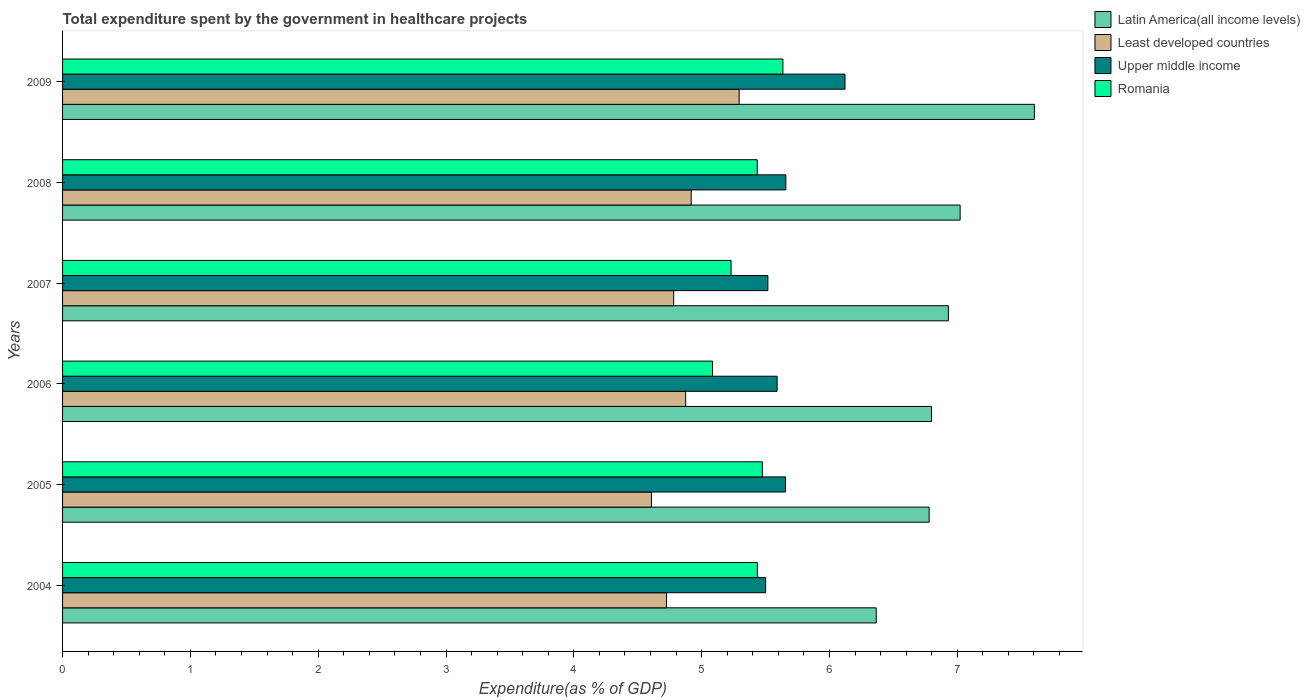How many different coloured bars are there?
Keep it short and to the point. 4. How many groups of bars are there?
Your answer should be compact. 6. Are the number of bars per tick equal to the number of legend labels?
Your answer should be compact. Yes. Are the number of bars on each tick of the Y-axis equal?
Keep it short and to the point. Yes. What is the label of the 5th group of bars from the top?
Keep it short and to the point. 2005. In how many cases, is the number of bars for a given year not equal to the number of legend labels?
Provide a succinct answer. 0. What is the total expenditure spent by the government in healthcare projects in Romania in 2004?
Your answer should be very brief. 5.44. Across all years, what is the maximum total expenditure spent by the government in healthcare projects in Upper middle income?
Ensure brevity in your answer.  6.12. Across all years, what is the minimum total expenditure spent by the government in healthcare projects in Latin America(all income levels)?
Provide a short and direct response. 6.37. In which year was the total expenditure spent by the government in healthcare projects in Upper middle income maximum?
Offer a very short reply. 2009. What is the total total expenditure spent by the government in healthcare projects in Least developed countries in the graph?
Ensure brevity in your answer.  29.2. What is the difference between the total expenditure spent by the government in healthcare projects in Least developed countries in 2005 and that in 2008?
Offer a terse response. -0.31. What is the difference between the total expenditure spent by the government in healthcare projects in Least developed countries in 2004 and the total expenditure spent by the government in healthcare projects in Upper middle income in 2008?
Your answer should be compact. -0.93. What is the average total expenditure spent by the government in healthcare projects in Least developed countries per year?
Your response must be concise. 4.87. In the year 2007, what is the difference between the total expenditure spent by the government in healthcare projects in Upper middle income and total expenditure spent by the government in healthcare projects in Latin America(all income levels)?
Your answer should be compact. -1.41. What is the ratio of the total expenditure spent by the government in healthcare projects in Upper middle income in 2005 to that in 2009?
Provide a short and direct response. 0.92. Is the total expenditure spent by the government in healthcare projects in Least developed countries in 2005 less than that in 2009?
Give a very brief answer. Yes. What is the difference between the highest and the second highest total expenditure spent by the government in healthcare projects in Least developed countries?
Make the answer very short. 0.38. What is the difference between the highest and the lowest total expenditure spent by the government in healthcare projects in Upper middle income?
Your answer should be very brief. 0.62. Is it the case that in every year, the sum of the total expenditure spent by the government in healthcare projects in Least developed countries and total expenditure spent by the government in healthcare projects in Romania is greater than the sum of total expenditure spent by the government in healthcare projects in Latin America(all income levels) and total expenditure spent by the government in healthcare projects in Upper middle income?
Offer a terse response. No. What does the 1st bar from the top in 2007 represents?
Provide a succinct answer. Romania. What does the 3rd bar from the bottom in 2009 represents?
Your answer should be compact. Upper middle income. Is it the case that in every year, the sum of the total expenditure spent by the government in healthcare projects in Least developed countries and total expenditure spent by the government in healthcare projects in Latin America(all income levels) is greater than the total expenditure spent by the government in healthcare projects in Romania?
Make the answer very short. Yes. Are all the bars in the graph horizontal?
Your answer should be very brief. Yes. How many years are there in the graph?
Make the answer very short. 6. Does the graph contain any zero values?
Provide a succinct answer. No. How many legend labels are there?
Your answer should be compact. 4. What is the title of the graph?
Your answer should be compact. Total expenditure spent by the government in healthcare projects. What is the label or title of the X-axis?
Make the answer very short. Expenditure(as % of GDP). What is the label or title of the Y-axis?
Provide a succinct answer. Years. What is the Expenditure(as % of GDP) in Latin America(all income levels) in 2004?
Your response must be concise. 6.37. What is the Expenditure(as % of GDP) of Least developed countries in 2004?
Your response must be concise. 4.72. What is the Expenditure(as % of GDP) of Upper middle income in 2004?
Make the answer very short. 5.5. What is the Expenditure(as % of GDP) in Romania in 2004?
Provide a succinct answer. 5.44. What is the Expenditure(as % of GDP) of Latin America(all income levels) in 2005?
Give a very brief answer. 6.78. What is the Expenditure(as % of GDP) of Least developed countries in 2005?
Give a very brief answer. 4.61. What is the Expenditure(as % of GDP) in Upper middle income in 2005?
Provide a short and direct response. 5.66. What is the Expenditure(as % of GDP) of Romania in 2005?
Ensure brevity in your answer.  5.48. What is the Expenditure(as % of GDP) in Latin America(all income levels) in 2006?
Offer a very short reply. 6.8. What is the Expenditure(as % of GDP) in Least developed countries in 2006?
Provide a short and direct response. 4.88. What is the Expenditure(as % of GDP) in Upper middle income in 2006?
Provide a succinct answer. 5.59. What is the Expenditure(as % of GDP) of Romania in 2006?
Keep it short and to the point. 5.09. What is the Expenditure(as % of GDP) in Latin America(all income levels) in 2007?
Ensure brevity in your answer.  6.93. What is the Expenditure(as % of GDP) in Least developed countries in 2007?
Offer a terse response. 4.78. What is the Expenditure(as % of GDP) in Upper middle income in 2007?
Provide a short and direct response. 5.52. What is the Expenditure(as % of GDP) in Romania in 2007?
Provide a succinct answer. 5.23. What is the Expenditure(as % of GDP) of Latin America(all income levels) in 2008?
Make the answer very short. 7.02. What is the Expenditure(as % of GDP) of Least developed countries in 2008?
Your response must be concise. 4.92. What is the Expenditure(as % of GDP) of Upper middle income in 2008?
Provide a short and direct response. 5.66. What is the Expenditure(as % of GDP) of Romania in 2008?
Keep it short and to the point. 5.44. What is the Expenditure(as % of GDP) in Latin America(all income levels) in 2009?
Offer a terse response. 7.6. What is the Expenditure(as % of GDP) in Least developed countries in 2009?
Keep it short and to the point. 5.29. What is the Expenditure(as % of GDP) of Upper middle income in 2009?
Make the answer very short. 6.12. What is the Expenditure(as % of GDP) in Romania in 2009?
Offer a very short reply. 5.64. Across all years, what is the maximum Expenditure(as % of GDP) in Latin America(all income levels)?
Make the answer very short. 7.6. Across all years, what is the maximum Expenditure(as % of GDP) of Least developed countries?
Make the answer very short. 5.29. Across all years, what is the maximum Expenditure(as % of GDP) of Upper middle income?
Make the answer very short. 6.12. Across all years, what is the maximum Expenditure(as % of GDP) of Romania?
Your answer should be very brief. 5.64. Across all years, what is the minimum Expenditure(as % of GDP) of Latin America(all income levels)?
Provide a short and direct response. 6.37. Across all years, what is the minimum Expenditure(as % of GDP) in Least developed countries?
Your answer should be compact. 4.61. Across all years, what is the minimum Expenditure(as % of GDP) of Upper middle income?
Your answer should be very brief. 5.5. Across all years, what is the minimum Expenditure(as % of GDP) in Romania?
Your answer should be very brief. 5.09. What is the total Expenditure(as % of GDP) of Latin America(all income levels) in the graph?
Offer a terse response. 41.5. What is the total Expenditure(as % of GDP) in Least developed countries in the graph?
Offer a very short reply. 29.2. What is the total Expenditure(as % of GDP) in Upper middle income in the graph?
Keep it short and to the point. 34.05. What is the total Expenditure(as % of GDP) in Romania in the graph?
Your answer should be compact. 32.3. What is the difference between the Expenditure(as % of GDP) of Latin America(all income levels) in 2004 and that in 2005?
Your answer should be very brief. -0.41. What is the difference between the Expenditure(as % of GDP) of Least developed countries in 2004 and that in 2005?
Offer a very short reply. 0.12. What is the difference between the Expenditure(as % of GDP) of Upper middle income in 2004 and that in 2005?
Provide a succinct answer. -0.15. What is the difference between the Expenditure(as % of GDP) of Romania in 2004 and that in 2005?
Provide a succinct answer. -0.04. What is the difference between the Expenditure(as % of GDP) in Latin America(all income levels) in 2004 and that in 2006?
Provide a short and direct response. -0.43. What is the difference between the Expenditure(as % of GDP) in Least developed countries in 2004 and that in 2006?
Make the answer very short. -0.15. What is the difference between the Expenditure(as % of GDP) of Upper middle income in 2004 and that in 2006?
Offer a very short reply. -0.09. What is the difference between the Expenditure(as % of GDP) in Romania in 2004 and that in 2006?
Ensure brevity in your answer.  0.35. What is the difference between the Expenditure(as % of GDP) of Latin America(all income levels) in 2004 and that in 2007?
Give a very brief answer. -0.56. What is the difference between the Expenditure(as % of GDP) of Least developed countries in 2004 and that in 2007?
Give a very brief answer. -0.06. What is the difference between the Expenditure(as % of GDP) of Upper middle income in 2004 and that in 2007?
Ensure brevity in your answer.  -0.02. What is the difference between the Expenditure(as % of GDP) of Romania in 2004 and that in 2007?
Your answer should be compact. 0.21. What is the difference between the Expenditure(as % of GDP) in Latin America(all income levels) in 2004 and that in 2008?
Make the answer very short. -0.66. What is the difference between the Expenditure(as % of GDP) in Least developed countries in 2004 and that in 2008?
Make the answer very short. -0.19. What is the difference between the Expenditure(as % of GDP) of Upper middle income in 2004 and that in 2008?
Provide a short and direct response. -0.16. What is the difference between the Expenditure(as % of GDP) in Romania in 2004 and that in 2008?
Give a very brief answer. 0. What is the difference between the Expenditure(as % of GDP) in Latin America(all income levels) in 2004 and that in 2009?
Offer a very short reply. -1.24. What is the difference between the Expenditure(as % of GDP) in Least developed countries in 2004 and that in 2009?
Ensure brevity in your answer.  -0.57. What is the difference between the Expenditure(as % of GDP) in Upper middle income in 2004 and that in 2009?
Give a very brief answer. -0.62. What is the difference between the Expenditure(as % of GDP) of Romania in 2004 and that in 2009?
Your answer should be very brief. -0.2. What is the difference between the Expenditure(as % of GDP) in Latin America(all income levels) in 2005 and that in 2006?
Make the answer very short. -0.02. What is the difference between the Expenditure(as % of GDP) of Least developed countries in 2005 and that in 2006?
Provide a succinct answer. -0.27. What is the difference between the Expenditure(as % of GDP) in Upper middle income in 2005 and that in 2006?
Ensure brevity in your answer.  0.07. What is the difference between the Expenditure(as % of GDP) in Romania in 2005 and that in 2006?
Ensure brevity in your answer.  0.39. What is the difference between the Expenditure(as % of GDP) in Latin America(all income levels) in 2005 and that in 2007?
Your answer should be very brief. -0.15. What is the difference between the Expenditure(as % of GDP) in Least developed countries in 2005 and that in 2007?
Your answer should be compact. -0.17. What is the difference between the Expenditure(as % of GDP) of Upper middle income in 2005 and that in 2007?
Your answer should be very brief. 0.14. What is the difference between the Expenditure(as % of GDP) of Romania in 2005 and that in 2007?
Your answer should be very brief. 0.24. What is the difference between the Expenditure(as % of GDP) in Latin America(all income levels) in 2005 and that in 2008?
Offer a very short reply. -0.24. What is the difference between the Expenditure(as % of GDP) of Least developed countries in 2005 and that in 2008?
Provide a short and direct response. -0.31. What is the difference between the Expenditure(as % of GDP) of Upper middle income in 2005 and that in 2008?
Provide a short and direct response. -0. What is the difference between the Expenditure(as % of GDP) of Romania in 2005 and that in 2008?
Your answer should be compact. 0.04. What is the difference between the Expenditure(as % of GDP) of Latin America(all income levels) in 2005 and that in 2009?
Offer a terse response. -0.82. What is the difference between the Expenditure(as % of GDP) of Least developed countries in 2005 and that in 2009?
Offer a terse response. -0.69. What is the difference between the Expenditure(as % of GDP) in Upper middle income in 2005 and that in 2009?
Offer a very short reply. -0.47. What is the difference between the Expenditure(as % of GDP) in Romania in 2005 and that in 2009?
Your response must be concise. -0.16. What is the difference between the Expenditure(as % of GDP) of Latin America(all income levels) in 2006 and that in 2007?
Keep it short and to the point. -0.13. What is the difference between the Expenditure(as % of GDP) in Least developed countries in 2006 and that in 2007?
Provide a short and direct response. 0.09. What is the difference between the Expenditure(as % of GDP) of Upper middle income in 2006 and that in 2007?
Your response must be concise. 0.07. What is the difference between the Expenditure(as % of GDP) of Romania in 2006 and that in 2007?
Your response must be concise. -0.15. What is the difference between the Expenditure(as % of GDP) in Latin America(all income levels) in 2006 and that in 2008?
Provide a succinct answer. -0.22. What is the difference between the Expenditure(as % of GDP) of Least developed countries in 2006 and that in 2008?
Give a very brief answer. -0.04. What is the difference between the Expenditure(as % of GDP) of Upper middle income in 2006 and that in 2008?
Give a very brief answer. -0.07. What is the difference between the Expenditure(as % of GDP) of Romania in 2006 and that in 2008?
Your response must be concise. -0.35. What is the difference between the Expenditure(as % of GDP) of Latin America(all income levels) in 2006 and that in 2009?
Keep it short and to the point. -0.8. What is the difference between the Expenditure(as % of GDP) of Least developed countries in 2006 and that in 2009?
Your answer should be very brief. -0.42. What is the difference between the Expenditure(as % of GDP) in Upper middle income in 2006 and that in 2009?
Keep it short and to the point. -0.53. What is the difference between the Expenditure(as % of GDP) in Romania in 2006 and that in 2009?
Make the answer very short. -0.55. What is the difference between the Expenditure(as % of GDP) in Latin America(all income levels) in 2007 and that in 2008?
Ensure brevity in your answer.  -0.09. What is the difference between the Expenditure(as % of GDP) of Least developed countries in 2007 and that in 2008?
Make the answer very short. -0.14. What is the difference between the Expenditure(as % of GDP) in Upper middle income in 2007 and that in 2008?
Provide a short and direct response. -0.14. What is the difference between the Expenditure(as % of GDP) in Romania in 2007 and that in 2008?
Give a very brief answer. -0.2. What is the difference between the Expenditure(as % of GDP) in Latin America(all income levels) in 2007 and that in 2009?
Your answer should be very brief. -0.67. What is the difference between the Expenditure(as % of GDP) in Least developed countries in 2007 and that in 2009?
Ensure brevity in your answer.  -0.51. What is the difference between the Expenditure(as % of GDP) in Upper middle income in 2007 and that in 2009?
Offer a very short reply. -0.6. What is the difference between the Expenditure(as % of GDP) of Romania in 2007 and that in 2009?
Your response must be concise. -0.41. What is the difference between the Expenditure(as % of GDP) of Latin America(all income levels) in 2008 and that in 2009?
Keep it short and to the point. -0.58. What is the difference between the Expenditure(as % of GDP) of Least developed countries in 2008 and that in 2009?
Your answer should be very brief. -0.38. What is the difference between the Expenditure(as % of GDP) in Upper middle income in 2008 and that in 2009?
Provide a short and direct response. -0.46. What is the difference between the Expenditure(as % of GDP) of Romania in 2008 and that in 2009?
Your answer should be compact. -0.2. What is the difference between the Expenditure(as % of GDP) in Latin America(all income levels) in 2004 and the Expenditure(as % of GDP) in Least developed countries in 2005?
Offer a very short reply. 1.76. What is the difference between the Expenditure(as % of GDP) in Latin America(all income levels) in 2004 and the Expenditure(as % of GDP) in Upper middle income in 2005?
Your response must be concise. 0.71. What is the difference between the Expenditure(as % of GDP) of Latin America(all income levels) in 2004 and the Expenditure(as % of GDP) of Romania in 2005?
Offer a terse response. 0.89. What is the difference between the Expenditure(as % of GDP) in Least developed countries in 2004 and the Expenditure(as % of GDP) in Upper middle income in 2005?
Your answer should be very brief. -0.93. What is the difference between the Expenditure(as % of GDP) in Least developed countries in 2004 and the Expenditure(as % of GDP) in Romania in 2005?
Your answer should be compact. -0.75. What is the difference between the Expenditure(as % of GDP) in Upper middle income in 2004 and the Expenditure(as % of GDP) in Romania in 2005?
Your answer should be compact. 0.03. What is the difference between the Expenditure(as % of GDP) in Latin America(all income levels) in 2004 and the Expenditure(as % of GDP) in Least developed countries in 2006?
Keep it short and to the point. 1.49. What is the difference between the Expenditure(as % of GDP) of Latin America(all income levels) in 2004 and the Expenditure(as % of GDP) of Upper middle income in 2006?
Give a very brief answer. 0.78. What is the difference between the Expenditure(as % of GDP) in Latin America(all income levels) in 2004 and the Expenditure(as % of GDP) in Romania in 2006?
Keep it short and to the point. 1.28. What is the difference between the Expenditure(as % of GDP) in Least developed countries in 2004 and the Expenditure(as % of GDP) in Upper middle income in 2006?
Make the answer very short. -0.87. What is the difference between the Expenditure(as % of GDP) of Least developed countries in 2004 and the Expenditure(as % of GDP) of Romania in 2006?
Your answer should be very brief. -0.36. What is the difference between the Expenditure(as % of GDP) of Upper middle income in 2004 and the Expenditure(as % of GDP) of Romania in 2006?
Offer a terse response. 0.42. What is the difference between the Expenditure(as % of GDP) in Latin America(all income levels) in 2004 and the Expenditure(as % of GDP) in Least developed countries in 2007?
Ensure brevity in your answer.  1.58. What is the difference between the Expenditure(as % of GDP) of Latin America(all income levels) in 2004 and the Expenditure(as % of GDP) of Upper middle income in 2007?
Offer a very short reply. 0.85. What is the difference between the Expenditure(as % of GDP) of Latin America(all income levels) in 2004 and the Expenditure(as % of GDP) of Romania in 2007?
Your answer should be very brief. 1.14. What is the difference between the Expenditure(as % of GDP) in Least developed countries in 2004 and the Expenditure(as % of GDP) in Upper middle income in 2007?
Ensure brevity in your answer.  -0.79. What is the difference between the Expenditure(as % of GDP) of Least developed countries in 2004 and the Expenditure(as % of GDP) of Romania in 2007?
Provide a short and direct response. -0.51. What is the difference between the Expenditure(as % of GDP) of Upper middle income in 2004 and the Expenditure(as % of GDP) of Romania in 2007?
Your response must be concise. 0.27. What is the difference between the Expenditure(as % of GDP) in Latin America(all income levels) in 2004 and the Expenditure(as % of GDP) in Least developed countries in 2008?
Provide a succinct answer. 1.45. What is the difference between the Expenditure(as % of GDP) of Latin America(all income levels) in 2004 and the Expenditure(as % of GDP) of Upper middle income in 2008?
Give a very brief answer. 0.71. What is the difference between the Expenditure(as % of GDP) in Least developed countries in 2004 and the Expenditure(as % of GDP) in Upper middle income in 2008?
Ensure brevity in your answer.  -0.93. What is the difference between the Expenditure(as % of GDP) in Least developed countries in 2004 and the Expenditure(as % of GDP) in Romania in 2008?
Offer a very short reply. -0.71. What is the difference between the Expenditure(as % of GDP) in Upper middle income in 2004 and the Expenditure(as % of GDP) in Romania in 2008?
Give a very brief answer. 0.07. What is the difference between the Expenditure(as % of GDP) of Latin America(all income levels) in 2004 and the Expenditure(as % of GDP) of Least developed countries in 2009?
Your answer should be compact. 1.07. What is the difference between the Expenditure(as % of GDP) in Latin America(all income levels) in 2004 and the Expenditure(as % of GDP) in Upper middle income in 2009?
Keep it short and to the point. 0.24. What is the difference between the Expenditure(as % of GDP) of Latin America(all income levels) in 2004 and the Expenditure(as % of GDP) of Romania in 2009?
Provide a succinct answer. 0.73. What is the difference between the Expenditure(as % of GDP) in Least developed countries in 2004 and the Expenditure(as % of GDP) in Upper middle income in 2009?
Your answer should be very brief. -1.4. What is the difference between the Expenditure(as % of GDP) of Least developed countries in 2004 and the Expenditure(as % of GDP) of Romania in 2009?
Keep it short and to the point. -0.91. What is the difference between the Expenditure(as % of GDP) of Upper middle income in 2004 and the Expenditure(as % of GDP) of Romania in 2009?
Make the answer very short. -0.14. What is the difference between the Expenditure(as % of GDP) in Latin America(all income levels) in 2005 and the Expenditure(as % of GDP) in Least developed countries in 2006?
Your answer should be compact. 1.9. What is the difference between the Expenditure(as % of GDP) of Latin America(all income levels) in 2005 and the Expenditure(as % of GDP) of Upper middle income in 2006?
Your answer should be compact. 1.19. What is the difference between the Expenditure(as % of GDP) of Latin America(all income levels) in 2005 and the Expenditure(as % of GDP) of Romania in 2006?
Your response must be concise. 1.69. What is the difference between the Expenditure(as % of GDP) in Least developed countries in 2005 and the Expenditure(as % of GDP) in Upper middle income in 2006?
Provide a succinct answer. -0.98. What is the difference between the Expenditure(as % of GDP) in Least developed countries in 2005 and the Expenditure(as % of GDP) in Romania in 2006?
Your response must be concise. -0.48. What is the difference between the Expenditure(as % of GDP) in Upper middle income in 2005 and the Expenditure(as % of GDP) in Romania in 2006?
Offer a terse response. 0.57. What is the difference between the Expenditure(as % of GDP) in Latin America(all income levels) in 2005 and the Expenditure(as % of GDP) in Least developed countries in 2007?
Make the answer very short. 2. What is the difference between the Expenditure(as % of GDP) of Latin America(all income levels) in 2005 and the Expenditure(as % of GDP) of Upper middle income in 2007?
Your answer should be very brief. 1.26. What is the difference between the Expenditure(as % of GDP) in Latin America(all income levels) in 2005 and the Expenditure(as % of GDP) in Romania in 2007?
Your response must be concise. 1.55. What is the difference between the Expenditure(as % of GDP) of Least developed countries in 2005 and the Expenditure(as % of GDP) of Upper middle income in 2007?
Offer a terse response. -0.91. What is the difference between the Expenditure(as % of GDP) of Least developed countries in 2005 and the Expenditure(as % of GDP) of Romania in 2007?
Offer a very short reply. -0.62. What is the difference between the Expenditure(as % of GDP) in Upper middle income in 2005 and the Expenditure(as % of GDP) in Romania in 2007?
Your response must be concise. 0.43. What is the difference between the Expenditure(as % of GDP) in Latin America(all income levels) in 2005 and the Expenditure(as % of GDP) in Least developed countries in 2008?
Make the answer very short. 1.86. What is the difference between the Expenditure(as % of GDP) in Latin America(all income levels) in 2005 and the Expenditure(as % of GDP) in Upper middle income in 2008?
Give a very brief answer. 1.12. What is the difference between the Expenditure(as % of GDP) in Latin America(all income levels) in 2005 and the Expenditure(as % of GDP) in Romania in 2008?
Offer a terse response. 1.34. What is the difference between the Expenditure(as % of GDP) in Least developed countries in 2005 and the Expenditure(as % of GDP) in Upper middle income in 2008?
Offer a very short reply. -1.05. What is the difference between the Expenditure(as % of GDP) of Least developed countries in 2005 and the Expenditure(as % of GDP) of Romania in 2008?
Offer a terse response. -0.83. What is the difference between the Expenditure(as % of GDP) in Upper middle income in 2005 and the Expenditure(as % of GDP) in Romania in 2008?
Offer a terse response. 0.22. What is the difference between the Expenditure(as % of GDP) of Latin America(all income levels) in 2005 and the Expenditure(as % of GDP) of Least developed countries in 2009?
Provide a short and direct response. 1.49. What is the difference between the Expenditure(as % of GDP) of Latin America(all income levels) in 2005 and the Expenditure(as % of GDP) of Upper middle income in 2009?
Offer a very short reply. 0.66. What is the difference between the Expenditure(as % of GDP) of Latin America(all income levels) in 2005 and the Expenditure(as % of GDP) of Romania in 2009?
Offer a very short reply. 1.14. What is the difference between the Expenditure(as % of GDP) in Least developed countries in 2005 and the Expenditure(as % of GDP) in Upper middle income in 2009?
Provide a succinct answer. -1.51. What is the difference between the Expenditure(as % of GDP) of Least developed countries in 2005 and the Expenditure(as % of GDP) of Romania in 2009?
Give a very brief answer. -1.03. What is the difference between the Expenditure(as % of GDP) of Upper middle income in 2005 and the Expenditure(as % of GDP) of Romania in 2009?
Ensure brevity in your answer.  0.02. What is the difference between the Expenditure(as % of GDP) in Latin America(all income levels) in 2006 and the Expenditure(as % of GDP) in Least developed countries in 2007?
Provide a short and direct response. 2.02. What is the difference between the Expenditure(as % of GDP) of Latin America(all income levels) in 2006 and the Expenditure(as % of GDP) of Upper middle income in 2007?
Offer a very short reply. 1.28. What is the difference between the Expenditure(as % of GDP) in Latin America(all income levels) in 2006 and the Expenditure(as % of GDP) in Romania in 2007?
Make the answer very short. 1.57. What is the difference between the Expenditure(as % of GDP) of Least developed countries in 2006 and the Expenditure(as % of GDP) of Upper middle income in 2007?
Your response must be concise. -0.64. What is the difference between the Expenditure(as % of GDP) in Least developed countries in 2006 and the Expenditure(as % of GDP) in Romania in 2007?
Give a very brief answer. -0.36. What is the difference between the Expenditure(as % of GDP) of Upper middle income in 2006 and the Expenditure(as % of GDP) of Romania in 2007?
Offer a terse response. 0.36. What is the difference between the Expenditure(as % of GDP) in Latin America(all income levels) in 2006 and the Expenditure(as % of GDP) in Least developed countries in 2008?
Provide a succinct answer. 1.88. What is the difference between the Expenditure(as % of GDP) of Latin America(all income levels) in 2006 and the Expenditure(as % of GDP) of Upper middle income in 2008?
Offer a very short reply. 1.14. What is the difference between the Expenditure(as % of GDP) of Latin America(all income levels) in 2006 and the Expenditure(as % of GDP) of Romania in 2008?
Provide a succinct answer. 1.36. What is the difference between the Expenditure(as % of GDP) in Least developed countries in 2006 and the Expenditure(as % of GDP) in Upper middle income in 2008?
Provide a short and direct response. -0.78. What is the difference between the Expenditure(as % of GDP) of Least developed countries in 2006 and the Expenditure(as % of GDP) of Romania in 2008?
Make the answer very short. -0.56. What is the difference between the Expenditure(as % of GDP) of Upper middle income in 2006 and the Expenditure(as % of GDP) of Romania in 2008?
Your answer should be compact. 0.16. What is the difference between the Expenditure(as % of GDP) in Latin America(all income levels) in 2006 and the Expenditure(as % of GDP) in Least developed countries in 2009?
Ensure brevity in your answer.  1.51. What is the difference between the Expenditure(as % of GDP) of Latin America(all income levels) in 2006 and the Expenditure(as % of GDP) of Upper middle income in 2009?
Give a very brief answer. 0.68. What is the difference between the Expenditure(as % of GDP) in Latin America(all income levels) in 2006 and the Expenditure(as % of GDP) in Romania in 2009?
Your answer should be compact. 1.16. What is the difference between the Expenditure(as % of GDP) in Least developed countries in 2006 and the Expenditure(as % of GDP) in Upper middle income in 2009?
Your response must be concise. -1.25. What is the difference between the Expenditure(as % of GDP) of Least developed countries in 2006 and the Expenditure(as % of GDP) of Romania in 2009?
Provide a short and direct response. -0.76. What is the difference between the Expenditure(as % of GDP) in Upper middle income in 2006 and the Expenditure(as % of GDP) in Romania in 2009?
Ensure brevity in your answer.  -0.05. What is the difference between the Expenditure(as % of GDP) in Latin America(all income levels) in 2007 and the Expenditure(as % of GDP) in Least developed countries in 2008?
Offer a very short reply. 2.01. What is the difference between the Expenditure(as % of GDP) in Latin America(all income levels) in 2007 and the Expenditure(as % of GDP) in Upper middle income in 2008?
Provide a short and direct response. 1.27. What is the difference between the Expenditure(as % of GDP) of Latin America(all income levels) in 2007 and the Expenditure(as % of GDP) of Romania in 2008?
Your answer should be very brief. 1.5. What is the difference between the Expenditure(as % of GDP) in Least developed countries in 2007 and the Expenditure(as % of GDP) in Upper middle income in 2008?
Keep it short and to the point. -0.88. What is the difference between the Expenditure(as % of GDP) of Least developed countries in 2007 and the Expenditure(as % of GDP) of Romania in 2008?
Ensure brevity in your answer.  -0.65. What is the difference between the Expenditure(as % of GDP) in Upper middle income in 2007 and the Expenditure(as % of GDP) in Romania in 2008?
Ensure brevity in your answer.  0.08. What is the difference between the Expenditure(as % of GDP) in Latin America(all income levels) in 2007 and the Expenditure(as % of GDP) in Least developed countries in 2009?
Give a very brief answer. 1.64. What is the difference between the Expenditure(as % of GDP) of Latin America(all income levels) in 2007 and the Expenditure(as % of GDP) of Upper middle income in 2009?
Keep it short and to the point. 0.81. What is the difference between the Expenditure(as % of GDP) in Latin America(all income levels) in 2007 and the Expenditure(as % of GDP) in Romania in 2009?
Your answer should be very brief. 1.29. What is the difference between the Expenditure(as % of GDP) of Least developed countries in 2007 and the Expenditure(as % of GDP) of Upper middle income in 2009?
Offer a very short reply. -1.34. What is the difference between the Expenditure(as % of GDP) of Least developed countries in 2007 and the Expenditure(as % of GDP) of Romania in 2009?
Provide a succinct answer. -0.85. What is the difference between the Expenditure(as % of GDP) of Upper middle income in 2007 and the Expenditure(as % of GDP) of Romania in 2009?
Provide a succinct answer. -0.12. What is the difference between the Expenditure(as % of GDP) of Latin America(all income levels) in 2008 and the Expenditure(as % of GDP) of Least developed countries in 2009?
Provide a succinct answer. 1.73. What is the difference between the Expenditure(as % of GDP) of Latin America(all income levels) in 2008 and the Expenditure(as % of GDP) of Upper middle income in 2009?
Give a very brief answer. 0.9. What is the difference between the Expenditure(as % of GDP) of Latin America(all income levels) in 2008 and the Expenditure(as % of GDP) of Romania in 2009?
Provide a succinct answer. 1.39. What is the difference between the Expenditure(as % of GDP) of Least developed countries in 2008 and the Expenditure(as % of GDP) of Upper middle income in 2009?
Provide a succinct answer. -1.2. What is the difference between the Expenditure(as % of GDP) in Least developed countries in 2008 and the Expenditure(as % of GDP) in Romania in 2009?
Your response must be concise. -0.72. What is the difference between the Expenditure(as % of GDP) of Upper middle income in 2008 and the Expenditure(as % of GDP) of Romania in 2009?
Provide a succinct answer. 0.02. What is the average Expenditure(as % of GDP) in Latin America(all income levels) per year?
Keep it short and to the point. 6.92. What is the average Expenditure(as % of GDP) of Least developed countries per year?
Offer a terse response. 4.87. What is the average Expenditure(as % of GDP) in Upper middle income per year?
Your response must be concise. 5.67. What is the average Expenditure(as % of GDP) in Romania per year?
Offer a terse response. 5.38. In the year 2004, what is the difference between the Expenditure(as % of GDP) of Latin America(all income levels) and Expenditure(as % of GDP) of Least developed countries?
Ensure brevity in your answer.  1.64. In the year 2004, what is the difference between the Expenditure(as % of GDP) of Latin America(all income levels) and Expenditure(as % of GDP) of Upper middle income?
Keep it short and to the point. 0.87. In the year 2004, what is the difference between the Expenditure(as % of GDP) of Latin America(all income levels) and Expenditure(as % of GDP) of Romania?
Your answer should be very brief. 0.93. In the year 2004, what is the difference between the Expenditure(as % of GDP) of Least developed countries and Expenditure(as % of GDP) of Upper middle income?
Give a very brief answer. -0.78. In the year 2004, what is the difference between the Expenditure(as % of GDP) in Least developed countries and Expenditure(as % of GDP) in Romania?
Ensure brevity in your answer.  -0.71. In the year 2004, what is the difference between the Expenditure(as % of GDP) of Upper middle income and Expenditure(as % of GDP) of Romania?
Ensure brevity in your answer.  0.06. In the year 2005, what is the difference between the Expenditure(as % of GDP) of Latin America(all income levels) and Expenditure(as % of GDP) of Least developed countries?
Your answer should be compact. 2.17. In the year 2005, what is the difference between the Expenditure(as % of GDP) in Latin America(all income levels) and Expenditure(as % of GDP) in Upper middle income?
Offer a terse response. 1.12. In the year 2005, what is the difference between the Expenditure(as % of GDP) of Latin America(all income levels) and Expenditure(as % of GDP) of Romania?
Make the answer very short. 1.31. In the year 2005, what is the difference between the Expenditure(as % of GDP) of Least developed countries and Expenditure(as % of GDP) of Upper middle income?
Your answer should be compact. -1.05. In the year 2005, what is the difference between the Expenditure(as % of GDP) of Least developed countries and Expenditure(as % of GDP) of Romania?
Make the answer very short. -0.87. In the year 2005, what is the difference between the Expenditure(as % of GDP) in Upper middle income and Expenditure(as % of GDP) in Romania?
Your answer should be compact. 0.18. In the year 2006, what is the difference between the Expenditure(as % of GDP) in Latin America(all income levels) and Expenditure(as % of GDP) in Least developed countries?
Offer a terse response. 1.92. In the year 2006, what is the difference between the Expenditure(as % of GDP) of Latin America(all income levels) and Expenditure(as % of GDP) of Upper middle income?
Offer a very short reply. 1.21. In the year 2006, what is the difference between the Expenditure(as % of GDP) of Latin America(all income levels) and Expenditure(as % of GDP) of Romania?
Provide a short and direct response. 1.71. In the year 2006, what is the difference between the Expenditure(as % of GDP) of Least developed countries and Expenditure(as % of GDP) of Upper middle income?
Your answer should be compact. -0.72. In the year 2006, what is the difference between the Expenditure(as % of GDP) of Least developed countries and Expenditure(as % of GDP) of Romania?
Provide a succinct answer. -0.21. In the year 2006, what is the difference between the Expenditure(as % of GDP) of Upper middle income and Expenditure(as % of GDP) of Romania?
Offer a terse response. 0.51. In the year 2007, what is the difference between the Expenditure(as % of GDP) in Latin America(all income levels) and Expenditure(as % of GDP) in Least developed countries?
Provide a short and direct response. 2.15. In the year 2007, what is the difference between the Expenditure(as % of GDP) in Latin America(all income levels) and Expenditure(as % of GDP) in Upper middle income?
Give a very brief answer. 1.41. In the year 2007, what is the difference between the Expenditure(as % of GDP) in Latin America(all income levels) and Expenditure(as % of GDP) in Romania?
Offer a very short reply. 1.7. In the year 2007, what is the difference between the Expenditure(as % of GDP) in Least developed countries and Expenditure(as % of GDP) in Upper middle income?
Offer a terse response. -0.74. In the year 2007, what is the difference between the Expenditure(as % of GDP) of Least developed countries and Expenditure(as % of GDP) of Romania?
Ensure brevity in your answer.  -0.45. In the year 2007, what is the difference between the Expenditure(as % of GDP) of Upper middle income and Expenditure(as % of GDP) of Romania?
Give a very brief answer. 0.29. In the year 2008, what is the difference between the Expenditure(as % of GDP) of Latin America(all income levels) and Expenditure(as % of GDP) of Least developed countries?
Keep it short and to the point. 2.1. In the year 2008, what is the difference between the Expenditure(as % of GDP) in Latin America(all income levels) and Expenditure(as % of GDP) in Upper middle income?
Your answer should be compact. 1.36. In the year 2008, what is the difference between the Expenditure(as % of GDP) in Latin America(all income levels) and Expenditure(as % of GDP) in Romania?
Make the answer very short. 1.59. In the year 2008, what is the difference between the Expenditure(as % of GDP) in Least developed countries and Expenditure(as % of GDP) in Upper middle income?
Keep it short and to the point. -0.74. In the year 2008, what is the difference between the Expenditure(as % of GDP) in Least developed countries and Expenditure(as % of GDP) in Romania?
Your response must be concise. -0.52. In the year 2008, what is the difference between the Expenditure(as % of GDP) in Upper middle income and Expenditure(as % of GDP) in Romania?
Ensure brevity in your answer.  0.22. In the year 2009, what is the difference between the Expenditure(as % of GDP) in Latin America(all income levels) and Expenditure(as % of GDP) in Least developed countries?
Provide a succinct answer. 2.31. In the year 2009, what is the difference between the Expenditure(as % of GDP) in Latin America(all income levels) and Expenditure(as % of GDP) in Upper middle income?
Your answer should be compact. 1.48. In the year 2009, what is the difference between the Expenditure(as % of GDP) of Latin America(all income levels) and Expenditure(as % of GDP) of Romania?
Give a very brief answer. 1.97. In the year 2009, what is the difference between the Expenditure(as % of GDP) in Least developed countries and Expenditure(as % of GDP) in Upper middle income?
Your response must be concise. -0.83. In the year 2009, what is the difference between the Expenditure(as % of GDP) in Least developed countries and Expenditure(as % of GDP) in Romania?
Your response must be concise. -0.34. In the year 2009, what is the difference between the Expenditure(as % of GDP) of Upper middle income and Expenditure(as % of GDP) of Romania?
Your answer should be compact. 0.49. What is the ratio of the Expenditure(as % of GDP) in Latin America(all income levels) in 2004 to that in 2005?
Ensure brevity in your answer.  0.94. What is the ratio of the Expenditure(as % of GDP) of Least developed countries in 2004 to that in 2005?
Offer a very short reply. 1.03. What is the ratio of the Expenditure(as % of GDP) of Upper middle income in 2004 to that in 2005?
Your answer should be very brief. 0.97. What is the ratio of the Expenditure(as % of GDP) of Latin America(all income levels) in 2004 to that in 2006?
Give a very brief answer. 0.94. What is the ratio of the Expenditure(as % of GDP) of Least developed countries in 2004 to that in 2006?
Provide a succinct answer. 0.97. What is the ratio of the Expenditure(as % of GDP) of Upper middle income in 2004 to that in 2006?
Offer a very short reply. 0.98. What is the ratio of the Expenditure(as % of GDP) in Romania in 2004 to that in 2006?
Make the answer very short. 1.07. What is the ratio of the Expenditure(as % of GDP) of Latin America(all income levels) in 2004 to that in 2007?
Your response must be concise. 0.92. What is the ratio of the Expenditure(as % of GDP) in Romania in 2004 to that in 2007?
Offer a terse response. 1.04. What is the ratio of the Expenditure(as % of GDP) of Latin America(all income levels) in 2004 to that in 2008?
Provide a short and direct response. 0.91. What is the ratio of the Expenditure(as % of GDP) of Least developed countries in 2004 to that in 2008?
Provide a short and direct response. 0.96. What is the ratio of the Expenditure(as % of GDP) in Upper middle income in 2004 to that in 2008?
Provide a short and direct response. 0.97. What is the ratio of the Expenditure(as % of GDP) of Romania in 2004 to that in 2008?
Offer a terse response. 1. What is the ratio of the Expenditure(as % of GDP) in Latin America(all income levels) in 2004 to that in 2009?
Give a very brief answer. 0.84. What is the ratio of the Expenditure(as % of GDP) of Least developed countries in 2004 to that in 2009?
Offer a very short reply. 0.89. What is the ratio of the Expenditure(as % of GDP) of Upper middle income in 2004 to that in 2009?
Your answer should be compact. 0.9. What is the ratio of the Expenditure(as % of GDP) of Romania in 2004 to that in 2009?
Your response must be concise. 0.96. What is the ratio of the Expenditure(as % of GDP) of Latin America(all income levels) in 2005 to that in 2006?
Offer a very short reply. 1. What is the ratio of the Expenditure(as % of GDP) in Least developed countries in 2005 to that in 2006?
Provide a succinct answer. 0.95. What is the ratio of the Expenditure(as % of GDP) of Upper middle income in 2005 to that in 2006?
Provide a short and direct response. 1.01. What is the ratio of the Expenditure(as % of GDP) in Romania in 2005 to that in 2006?
Give a very brief answer. 1.08. What is the ratio of the Expenditure(as % of GDP) in Latin America(all income levels) in 2005 to that in 2007?
Offer a very short reply. 0.98. What is the ratio of the Expenditure(as % of GDP) of Least developed countries in 2005 to that in 2007?
Offer a very short reply. 0.96. What is the ratio of the Expenditure(as % of GDP) in Upper middle income in 2005 to that in 2007?
Your answer should be compact. 1.02. What is the ratio of the Expenditure(as % of GDP) of Romania in 2005 to that in 2007?
Offer a very short reply. 1.05. What is the ratio of the Expenditure(as % of GDP) in Latin America(all income levels) in 2005 to that in 2008?
Offer a very short reply. 0.97. What is the ratio of the Expenditure(as % of GDP) of Least developed countries in 2005 to that in 2008?
Your answer should be compact. 0.94. What is the ratio of the Expenditure(as % of GDP) of Romania in 2005 to that in 2008?
Offer a terse response. 1.01. What is the ratio of the Expenditure(as % of GDP) in Latin America(all income levels) in 2005 to that in 2009?
Offer a terse response. 0.89. What is the ratio of the Expenditure(as % of GDP) of Least developed countries in 2005 to that in 2009?
Your answer should be compact. 0.87. What is the ratio of the Expenditure(as % of GDP) of Upper middle income in 2005 to that in 2009?
Keep it short and to the point. 0.92. What is the ratio of the Expenditure(as % of GDP) of Romania in 2005 to that in 2009?
Ensure brevity in your answer.  0.97. What is the ratio of the Expenditure(as % of GDP) of Latin America(all income levels) in 2006 to that in 2007?
Offer a very short reply. 0.98. What is the ratio of the Expenditure(as % of GDP) of Least developed countries in 2006 to that in 2007?
Offer a terse response. 1.02. What is the ratio of the Expenditure(as % of GDP) in Upper middle income in 2006 to that in 2007?
Make the answer very short. 1.01. What is the ratio of the Expenditure(as % of GDP) in Romania in 2006 to that in 2007?
Provide a short and direct response. 0.97. What is the ratio of the Expenditure(as % of GDP) in Latin America(all income levels) in 2006 to that in 2008?
Your answer should be compact. 0.97. What is the ratio of the Expenditure(as % of GDP) of Least developed countries in 2006 to that in 2008?
Give a very brief answer. 0.99. What is the ratio of the Expenditure(as % of GDP) of Upper middle income in 2006 to that in 2008?
Make the answer very short. 0.99. What is the ratio of the Expenditure(as % of GDP) in Romania in 2006 to that in 2008?
Provide a short and direct response. 0.94. What is the ratio of the Expenditure(as % of GDP) in Latin America(all income levels) in 2006 to that in 2009?
Offer a very short reply. 0.89. What is the ratio of the Expenditure(as % of GDP) in Least developed countries in 2006 to that in 2009?
Give a very brief answer. 0.92. What is the ratio of the Expenditure(as % of GDP) of Upper middle income in 2006 to that in 2009?
Give a very brief answer. 0.91. What is the ratio of the Expenditure(as % of GDP) in Romania in 2006 to that in 2009?
Make the answer very short. 0.9. What is the ratio of the Expenditure(as % of GDP) in Latin America(all income levels) in 2007 to that in 2008?
Provide a short and direct response. 0.99. What is the ratio of the Expenditure(as % of GDP) in Least developed countries in 2007 to that in 2008?
Ensure brevity in your answer.  0.97. What is the ratio of the Expenditure(as % of GDP) of Upper middle income in 2007 to that in 2008?
Your response must be concise. 0.98. What is the ratio of the Expenditure(as % of GDP) of Romania in 2007 to that in 2008?
Offer a very short reply. 0.96. What is the ratio of the Expenditure(as % of GDP) in Latin America(all income levels) in 2007 to that in 2009?
Your answer should be compact. 0.91. What is the ratio of the Expenditure(as % of GDP) of Least developed countries in 2007 to that in 2009?
Ensure brevity in your answer.  0.9. What is the ratio of the Expenditure(as % of GDP) of Upper middle income in 2007 to that in 2009?
Your answer should be compact. 0.9. What is the ratio of the Expenditure(as % of GDP) in Romania in 2007 to that in 2009?
Offer a terse response. 0.93. What is the ratio of the Expenditure(as % of GDP) of Latin America(all income levels) in 2008 to that in 2009?
Give a very brief answer. 0.92. What is the ratio of the Expenditure(as % of GDP) of Least developed countries in 2008 to that in 2009?
Offer a very short reply. 0.93. What is the ratio of the Expenditure(as % of GDP) in Upper middle income in 2008 to that in 2009?
Offer a very short reply. 0.92. What is the ratio of the Expenditure(as % of GDP) in Romania in 2008 to that in 2009?
Ensure brevity in your answer.  0.96. What is the difference between the highest and the second highest Expenditure(as % of GDP) of Latin America(all income levels)?
Your answer should be compact. 0.58. What is the difference between the highest and the second highest Expenditure(as % of GDP) in Least developed countries?
Ensure brevity in your answer.  0.38. What is the difference between the highest and the second highest Expenditure(as % of GDP) of Upper middle income?
Offer a very short reply. 0.46. What is the difference between the highest and the second highest Expenditure(as % of GDP) in Romania?
Offer a terse response. 0.16. What is the difference between the highest and the lowest Expenditure(as % of GDP) in Latin America(all income levels)?
Your answer should be very brief. 1.24. What is the difference between the highest and the lowest Expenditure(as % of GDP) in Least developed countries?
Keep it short and to the point. 0.69. What is the difference between the highest and the lowest Expenditure(as % of GDP) in Upper middle income?
Keep it short and to the point. 0.62. What is the difference between the highest and the lowest Expenditure(as % of GDP) of Romania?
Provide a short and direct response. 0.55. 